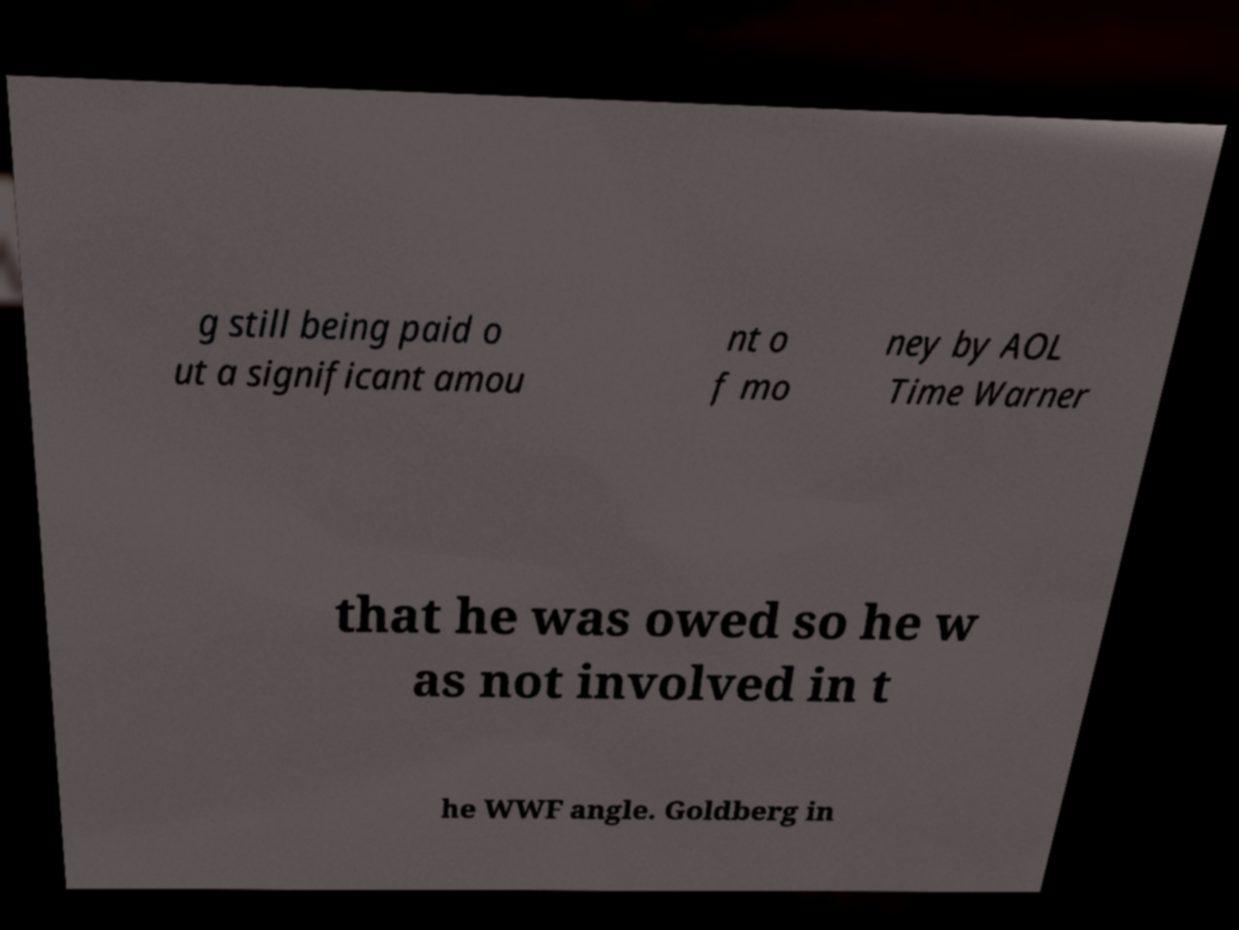Please identify and transcribe the text found in this image. g still being paid o ut a significant amou nt o f mo ney by AOL Time Warner that he was owed so he w as not involved in t he WWF angle. Goldberg in 